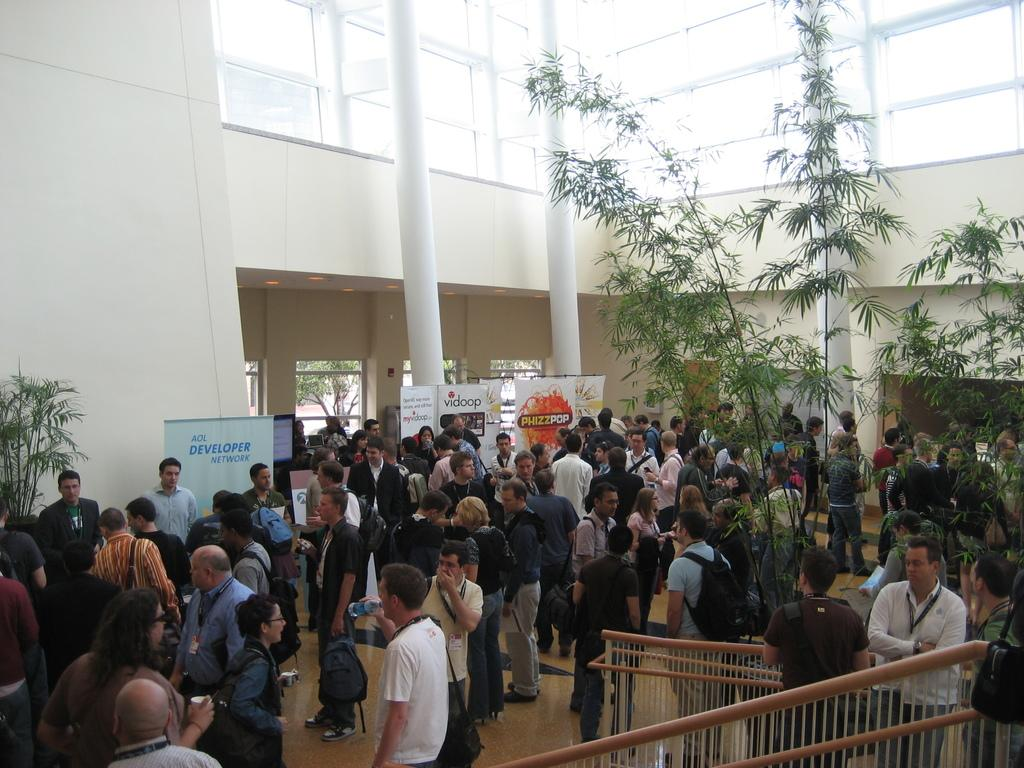What is the setting of the image? The image depicts an event inside a building. Can you describe the crowd in the image? There are a lot of people gathered on the floor. What can be seen behind the crowd? There are different banners visible behind the crowd. What type of blade is being used to cut the current in the image? There is no blade or current present in the image; it depicts an event with a crowd and banners. 